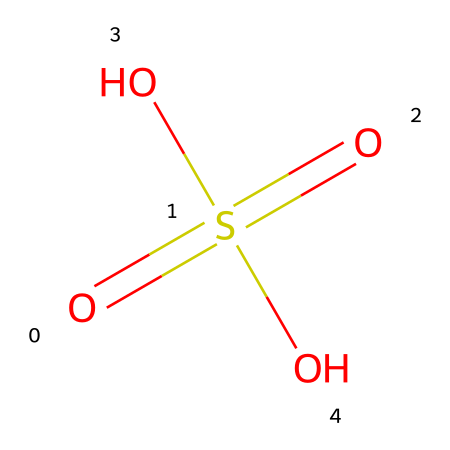What is the name of this chemical? The SMILES representation indicates the structure corresponds to a chemical commonly known as sulfuric acid.
Answer: sulfuric acid How many oxygen atoms are present in this chemical? Analyzing the SMILES representation, there are four oxygen atoms indicated in the structure.
Answer: four What is the total number of hydrogen atoms in this chemical? In the SMILES structure, there are two hydroxyl groups (O-H) which contribute two hydrogen atoms, resulting in a total of two hydrogen atoms.
Answer: two What is the oxidation state of sulfur in this chemical? By examining the structure, sulfur (S) has an oxidation state of +6, as it is bonded to four oxygen atoms (with a total contribution of -8), making the overall charge balance to zero.
Answer: +6 Why is this chemical classified as an acid? This chemical is classified as an acid because it can donate protons (H+) due to the presence of hydroxyl groups (-OH) in its molecular structure, making it an acid according to the Brønsted-Lowry definition.
Answer: it donates protons What is the significance of this chemical in car batteries? Sulfuric acid is used in car batteries because it acts as an electrolyte, facilitating the flow of electric current between the lead plates.
Answer: electrolyte How does the presence of sulfur impact the reactivity of this acid? The presence of sulfur in sulfuric acid enhances its reactivity due to its ability to form strong bonds with oxygen, making it a strong acid that can react with many materials.
Answer: enhances reactivity 